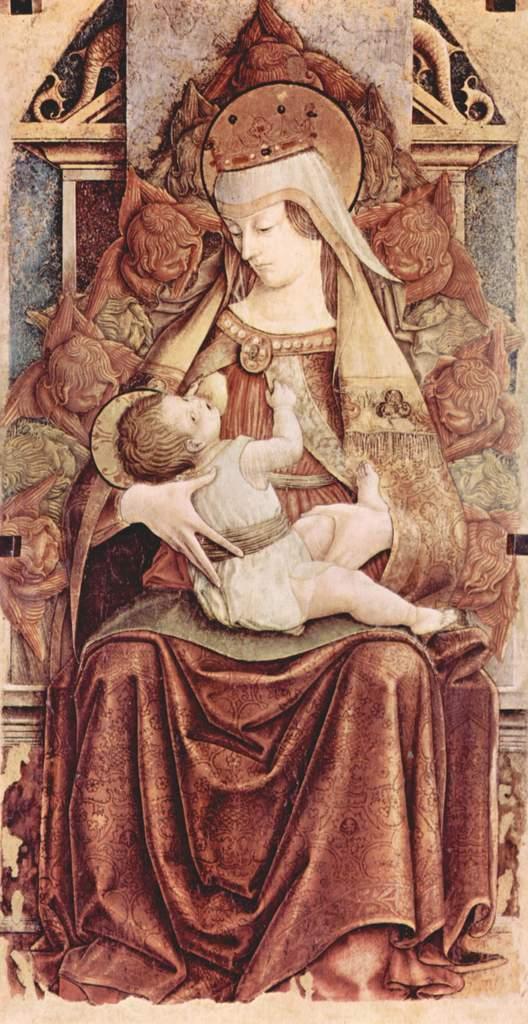How would you summarize this image in a sentence or two? In this image there is a painting of a woman sitting on the chair and holding a baby in her hands. In the background there is a wall with carvings. 